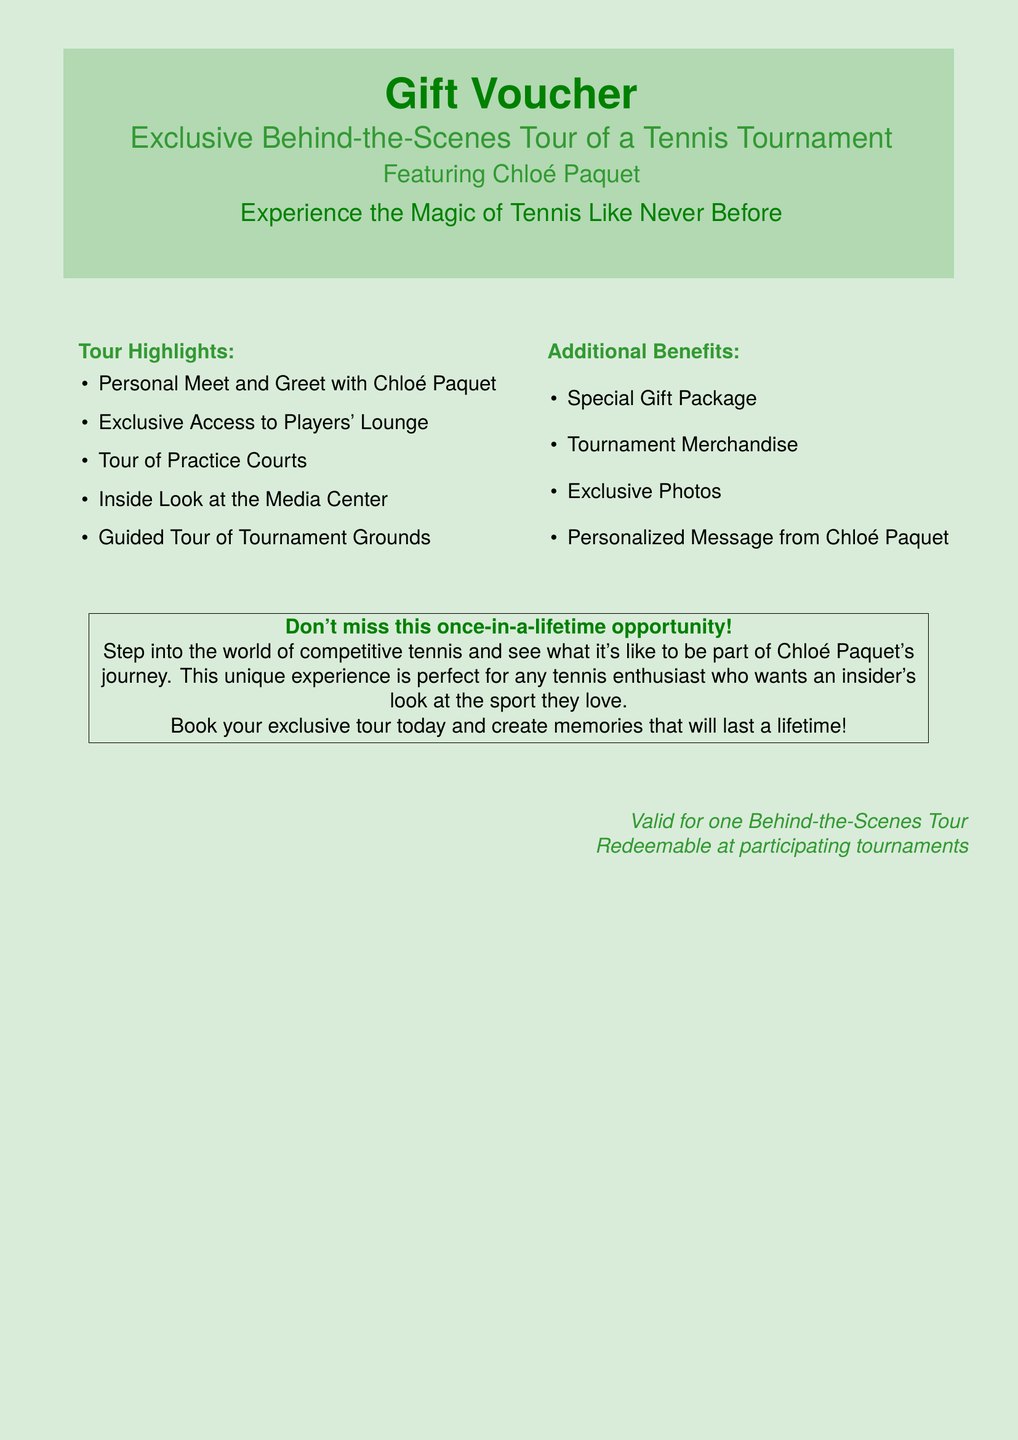what is the main purpose of the voucher? The voucher is intended for an exclusive behind-the-scenes tour of a tennis tournament.
Answer: exclusive behind-the-scenes tour who is featured in the tour? Chloé Paquet is the highlighted player in the tour.
Answer: Chloé Paquet how many highlights are listed in the tour? The document lists five highlights of the tour.
Answer: five what is one of the additional benefits mentioned? A special gift package is one of the additional benefits of the tour.
Answer: special gift package what should participants do to create memories? Participants should book their exclusive tour to create lasting memories.
Answer: book your exclusive tour is the voucher valid for multiple tours? The voucher is valid for one behind-the-scenes tour only.
Answer: one what type of message will Chloé Paquet provide? The document mentions a personalized message from Chloé Paquet.
Answer: personalized message in what setting will the tour take place? The tour will take place at a tennis tournament.
Answer: tennis tournament 